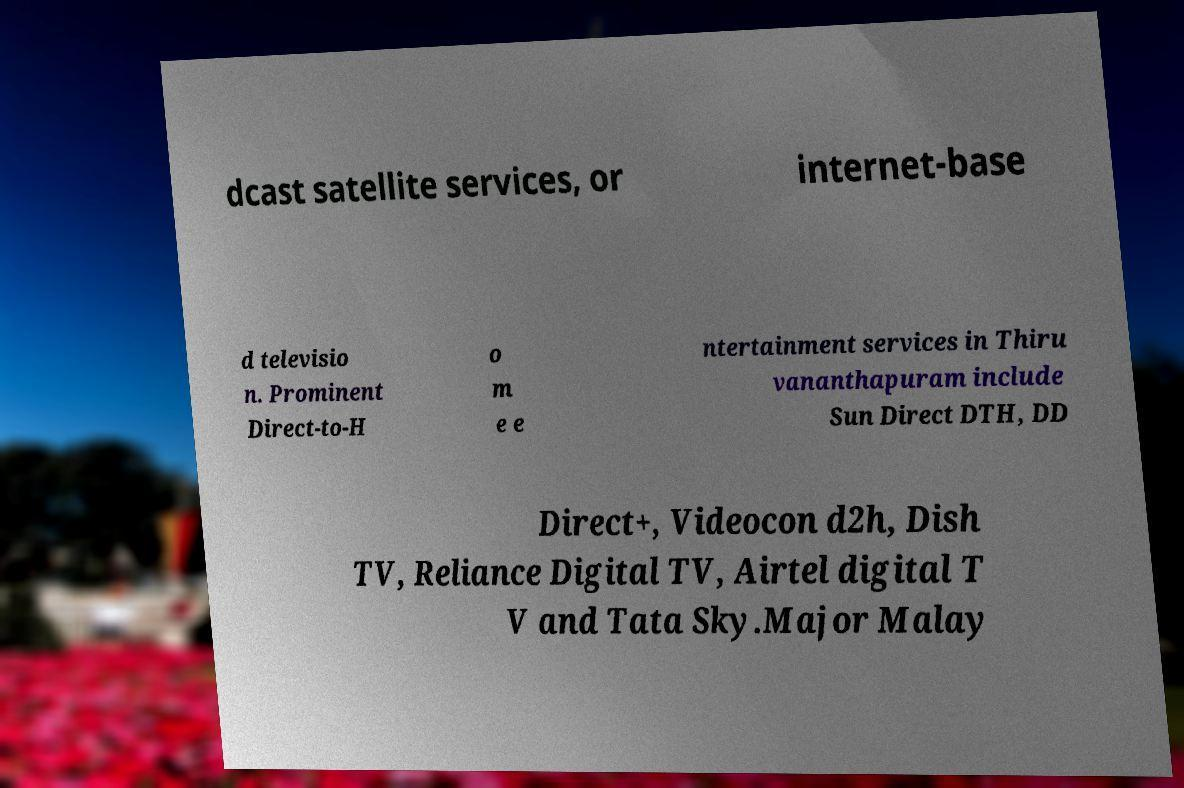Can you read and provide the text displayed in the image?This photo seems to have some interesting text. Can you extract and type it out for me? dcast satellite services, or internet-base d televisio n. Prominent Direct-to-H o m e e ntertainment services in Thiru vananthapuram include Sun Direct DTH, DD Direct+, Videocon d2h, Dish TV, Reliance Digital TV, Airtel digital T V and Tata Sky.Major Malay 